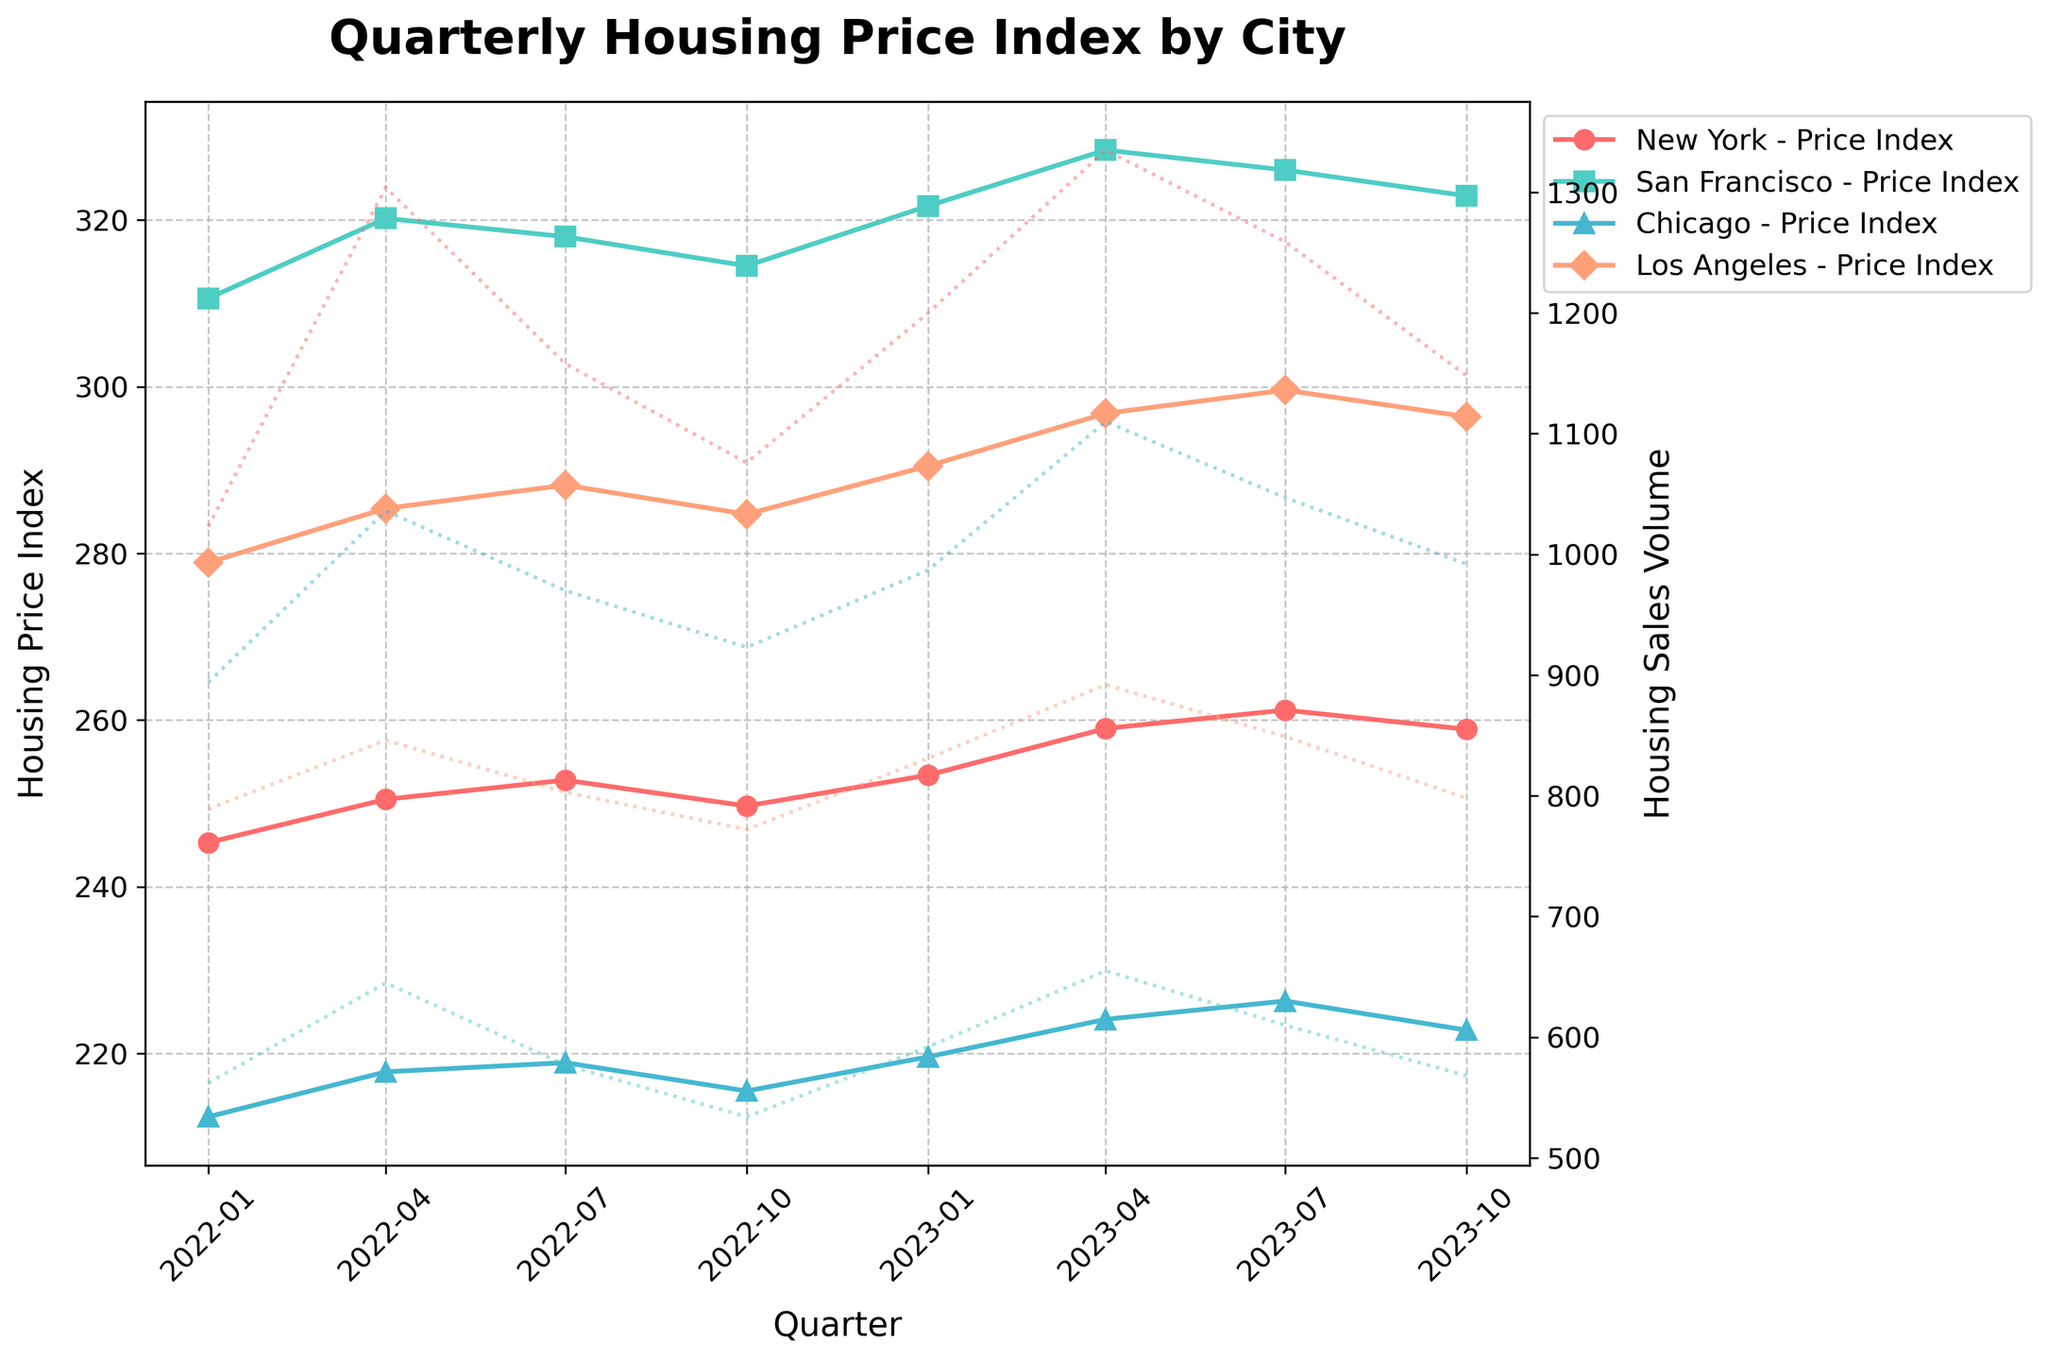What is the title of the plot? The title of the plot is located at the top and it reads "Quarterly Housing Price Index by City".
Answer: Quarterly Housing Price Index by City Which city shows the highest Housing Price Index during the time period? By looking at the lines on the plot, San Francisco has the highest Housing Price Index throughout all the quarters.
Answer: San Francisco In which quarter did Chicago see the highest Housing Sales Volume? To find this, one should look at the secondary axis representing sales volume and identify the peak point for Chicago, which is in 2023-Q2.
Answer: 2023-Q2 How does the Housing Price Index of New York change from 2022-Q1 to 2023-Q4? The Housing Price Index for New York starts at 245.3 in 2022-Q1 and ends at 258.9 in 2023-Q4, indicating a general increase over the period.
Answer: Increase What is the overall trend of Housing Sales Volume in Los Angeles throughout the time period? The plot shows Los Angeles’ Housing Sales Volume oscillating with peaks and troughs but generally increasing slightly from 789 in 2022-Q1 to higher values in subsequent quarters.
Answer: Gradually Increasing Which city experienced the greatest increase in Housing Price Index from 2022-Q1 to 2023-Q4? To determine this, we compare the Housing Price Indices for each city at the start and end of the time period. San Francisco increased from 310.6 to 322.9, which is the largest numerical increase.
Answer: San Francisco Is the Housing Sales Volume higher for New York or Los Angeles in 2023-Q3? By examining the plot, in 2023-Q3, New York's Housing Sales Volume is 1259 while Los Angeles' is 849.
Answer: New York During which quarter did San Francisco experience a drop in both Housing Price Index and Housing Sales Volume? By following San Francisco's lines on the plot, both indices decrease in 2022-Q4.
Answer: 2022-Q4 What is the difference in Housing Price Index between New York and Chicago in 2022-Q2? New York's Housing Price Index in 2022-Q2 is 250.5 and Chicago's is 217.8, resulting in a difference of 32.7.
Answer: 32.7 Which city shows the smallest fluctuation in Housing Sales Volume during the time period? Looking at the range of sales volumes for each city, Chicago has the smallest fluctuation, with values varying between 893 and 1100.
Answer: Chicago 